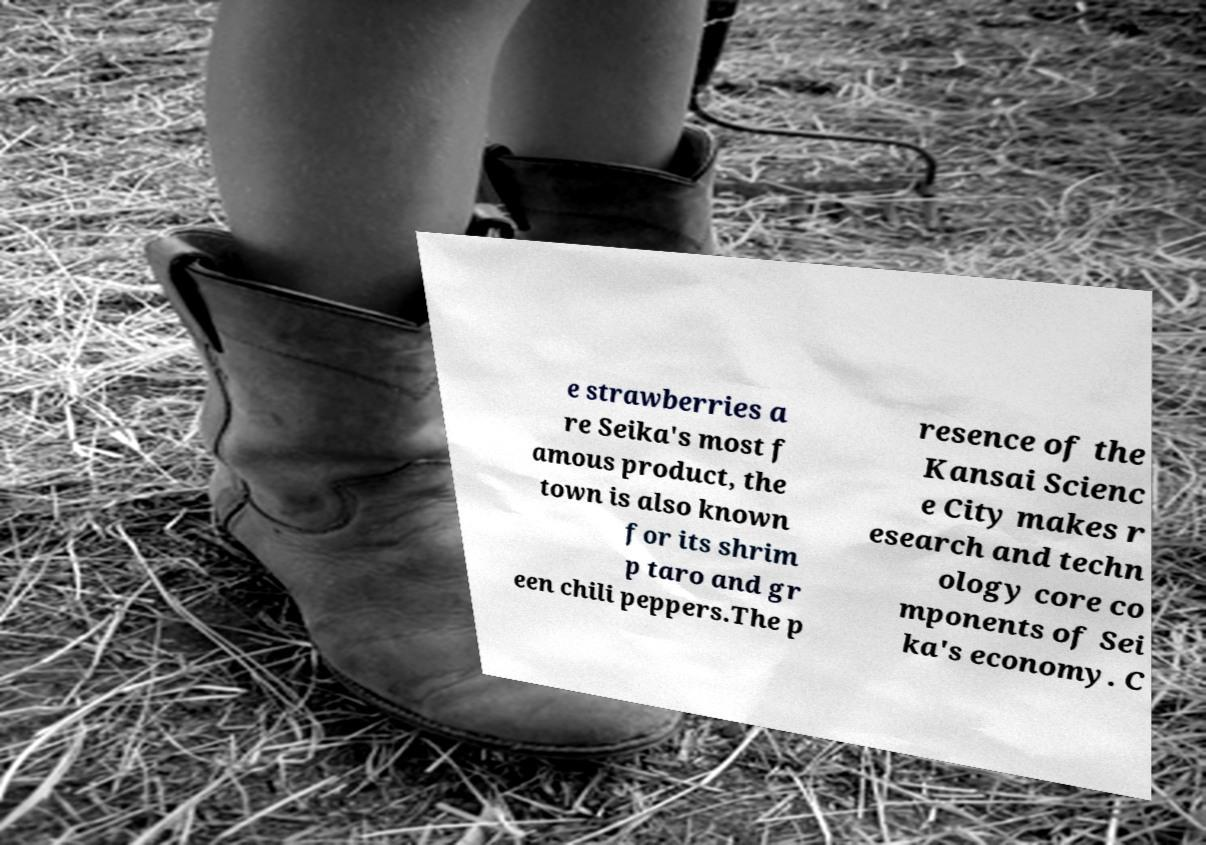Can you accurately transcribe the text from the provided image for me? e strawberries a re Seika's most f amous product, the town is also known for its shrim p taro and gr een chili peppers.The p resence of the Kansai Scienc e City makes r esearch and techn ology core co mponents of Sei ka's economy. C 